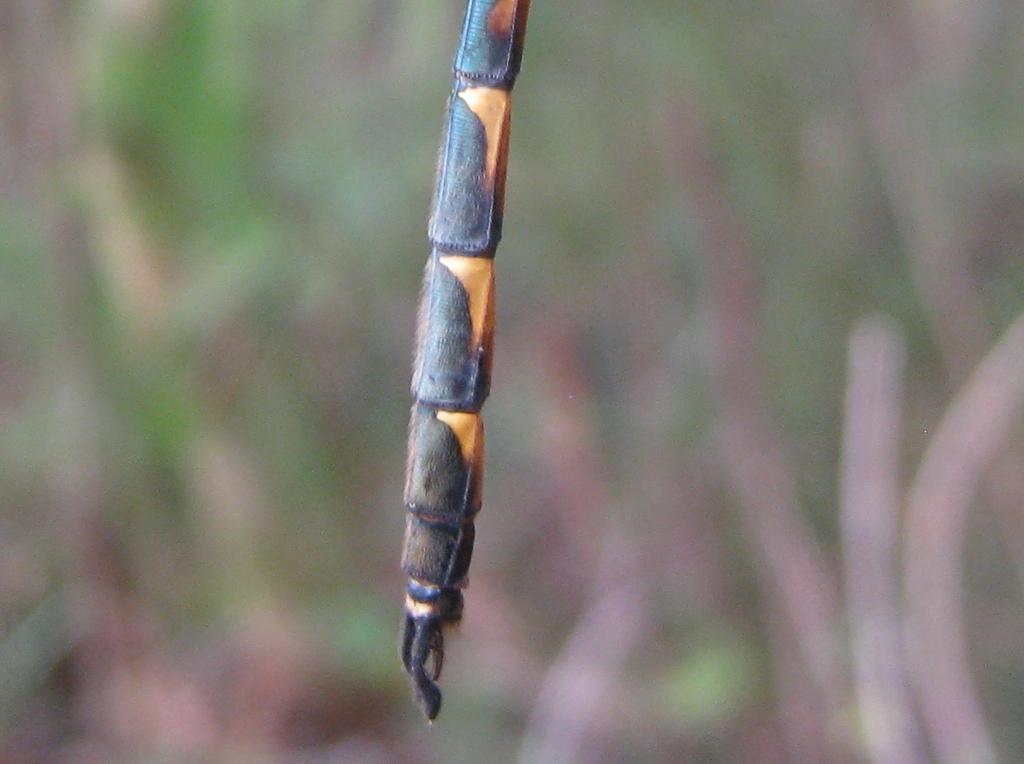What is the main subject of the image? The main subject of the image is an insect leg. Can you describe the background of the image? The background of the image is blurred. What type of straw is being used to measure the distance between the insect leg and the bag in the image? There is no straw, distance measurement, or bag present in the image. 